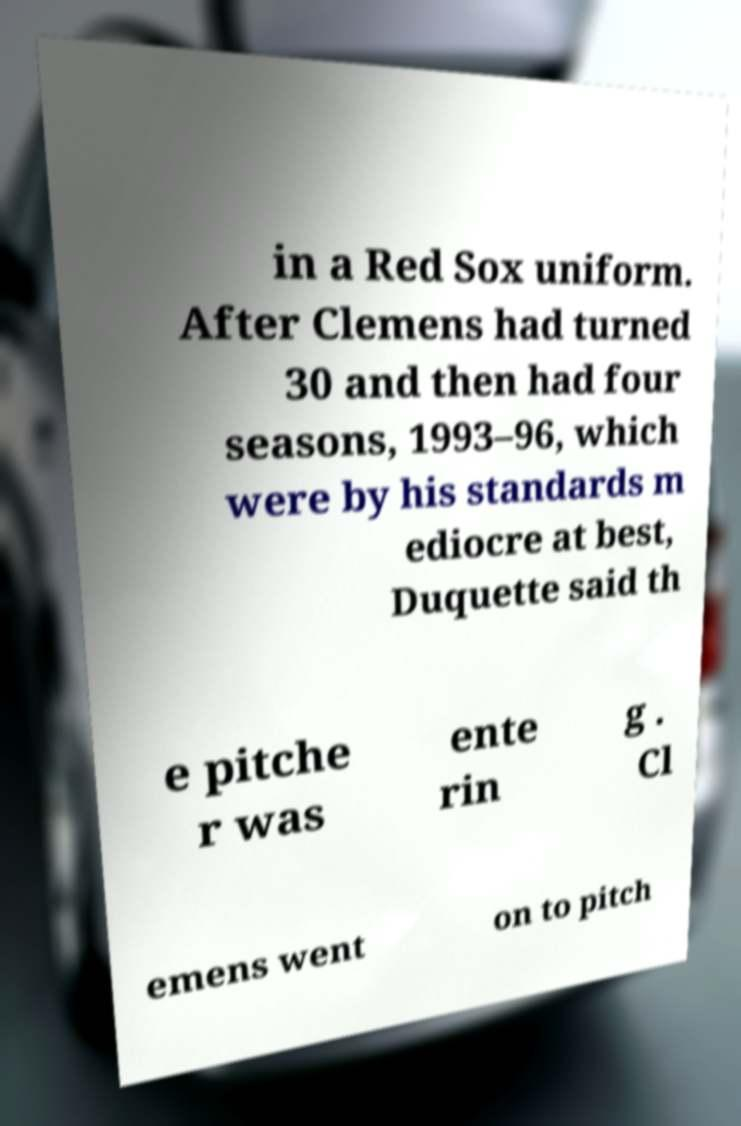There's text embedded in this image that I need extracted. Can you transcribe it verbatim? in a Red Sox uniform. After Clemens had turned 30 and then had four seasons, 1993–96, which were by his standards m ediocre at best, Duquette said th e pitche r was ente rin g . Cl emens went on to pitch 